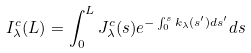<formula> <loc_0><loc_0><loc_500><loc_500>I ^ { c } _ { \lambda } ( L ) = \int ^ { L } _ { 0 } J ^ { c } _ { \lambda } ( s ) e ^ { - \int ^ { s } _ { 0 } k _ { \lambda } ( s ^ { \prime } ) d s ^ { \prime } } d s</formula> 